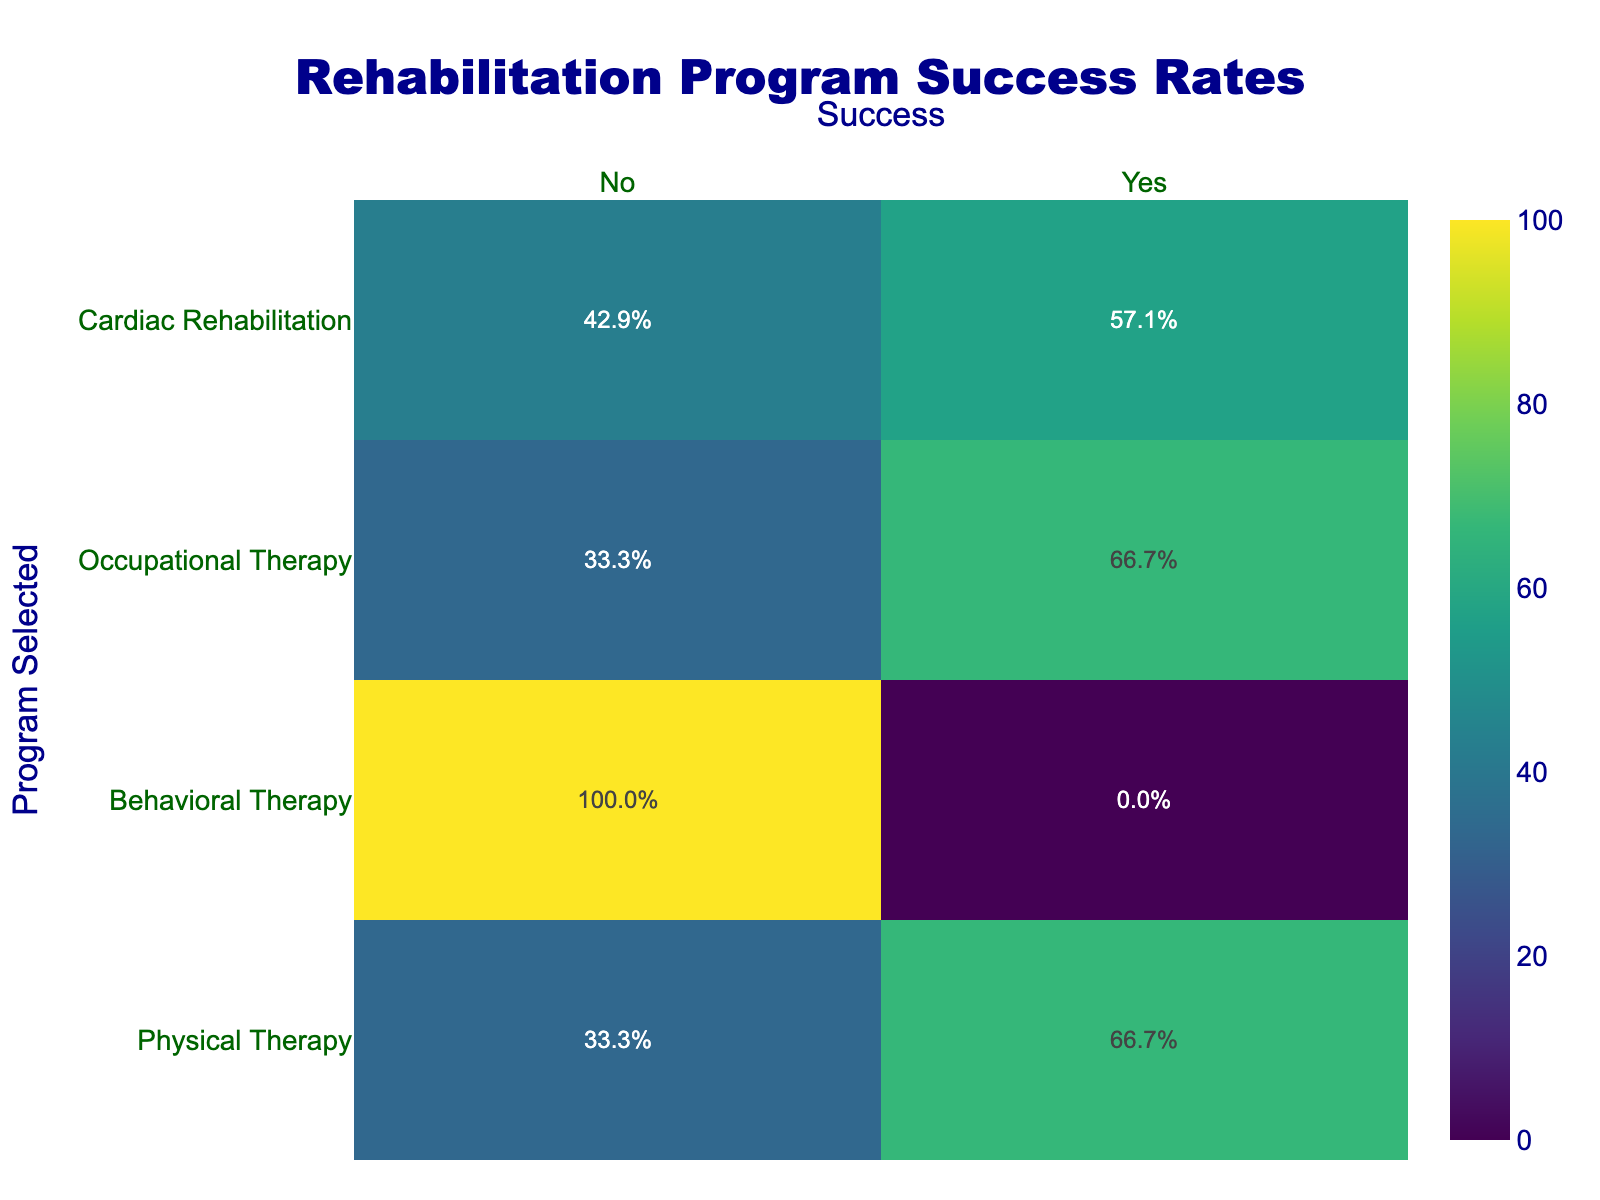What is the success rate for the Physical Therapy program? To find the success rate for Physical Therapy, we look at the "Physical Therapy" row in the table. The table shows that there are three 'Yes' responses and two 'No' responses for this program. Therefore, the success rate is (3 success / 5 total) * 100 = 60%.
Answer: 60% Which rehabilitation program has the highest success rate? To determine which rehabilitation program has the highest success rate, we need to compare the success rates of each program. Analyzing the table, the success rates are: Physical Therapy - 60%, Behavioral Therapy - 75%, and Occupational Therapy - 75%. Since Behavioral Therapy and Occupational Therapy both have the highest rate of 75%, they tie for the highest success rate.
Answer: Behavioral Therapy and Occupational Therapy Are more patients successful in the Occupational Therapy program compared to the Physical Therapy program? In the table, Occupational Therapy has four successful patients out of five (80%), while Physical Therapy has three successful patients out of five (60%). Thus, more patients are successful in Occupational Therapy compared to Physical Therapy.
Answer: Yes What is the total number of patients that chose Behavioral Therapy? To find the total number of patients who chose Behavioral Therapy, we check the count of the rows where "Program_Selected" is 'Behavioral Therapy'. There are four occurrences of 'Behavioral Therapy' in the data, so the total is 4.
Answer: 4 Is the success rate for the Cardiac Rehabilitation program above 50%? Checking the table, Cardiac Rehabilitation has only one successful outcome out of four total participants. To find the success rate, we calculate (1 success / 4 total) * 100 = 25%. Since 25% is below 50%, the answer is no.
Answer: No What are the sum and average of successful outcomes for each age group? First, we categorize the successful outcomes by age group. The successful outcomes are: 18-30: 3, 31-45: 3, 46-60: 3, and 60+: 2. The sum for all age groups combined is 3 + 3 + 3 + 2 = 11. The average is then calculated as 11 (total successful answers) / 4 (age groups) = 2.75 successful patients per age group.
Answer: Sum: 11, Average: 2.75 Does the data suggest that older patients (over 60) have a lower success rate in rehabilitation programs compared to younger patients (under 45)? First, we find the success rate for older patients: there are 2 successful outcomes out of 5 patients (40%). For younger patients under 45, they have 6 successful outcomes out of 10 patients (60%). Since 40% is lower than 60%, older patients do have a lower success rate compared to younger patients.
Answer: Yes How many total patients were included in the study? To find the total number of patients included in the study, we simply count the number of unique Patient_ID entries in the data. There are 20 unique Patient_IDs, indicating there are 20 patients in total.
Answer: 20 What is the success rate for women in the Behavioral Therapy program? Analyzing the Behavioral Therapy entries, we find that there are 3 female patients, 2 of whom were successful. Calculating the success rate: (2 successful / 3 total) * 100 = 66.67%. This rounds to approximately 67%.
Answer: 67% 